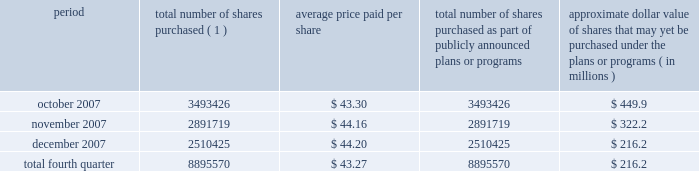Issuer purchases of equity securities during the three months ended december 31 , 2007 , we repurchased 8895570 shares of our class a common stock for an aggregate of $ 385.1 million pursuant to the $ 1.5 billion stock repurchase program publicly announced in february 2007 , as follows : period total number of shares purchased ( 1 ) average price paid per share total number of shares purchased as part of publicly announced plans or programs approximate dollar value of shares that may yet be purchased under the plans or programs ( in millions ) .
( 1 ) issuer repurchases pursuant to the $ 1.5 billion stock repurchase program publicly announced in february 2007 .
Under this program , our management was authorized through february 2008 to purchase shares from time to time through open market purchases or privately negotiated transactions at prevailing prices as permitted by securities laws and other legal requirements , and subject to market conditions and other factors .
To facilitate repurchases , we typically made purchases pursuant to trading plans under rule 10b5-1 of the exchange act , which allow us to repurchase shares during periods when we otherwise might be prevented from doing so under insider trading laws or because of self-imposed trading blackout periods .
Subsequent to december 31 , 2007 , we repurchased 4.3 million shares of our class a common stock for an aggregate of $ 163.7 million pursuant to this program .
In february 2008 , our board of directors approved a new stock repurchase program , pursuant to which we are authorized to purchase up to an additional $ 1.5 billion of our class a common stock .
Purchases under this stock repurchase program are subject to us having available cash to fund repurchases , as further described in item 1a of this annual report under the caption 201crisk factors 2014we anticipate that we may need additional financing to fund our stock repurchase programs , to refinance our existing indebtedness and to fund future growth and expansion initiatives 201d and item 7 of this annual report under the caption 201cmanagement 2019s discussion and analysis of financial condition and results of operations 2014liquidity and capital resources . 201d .
In q1 2008 , what was the average cost per share for repurchased shares in that quarter? 
Computations: ((163.7 * 1000000) / (4.3 * 1000000))
Answer: 38.06977. 